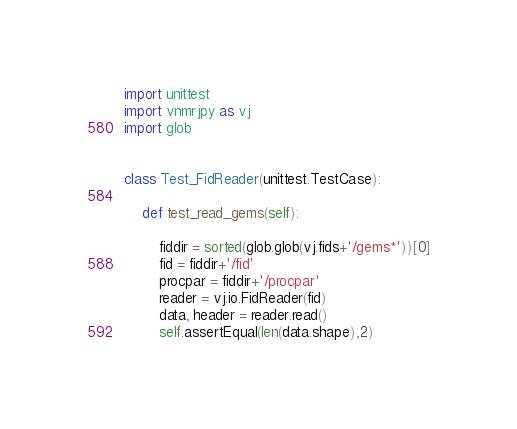<code> <loc_0><loc_0><loc_500><loc_500><_Python_>import unittest
import vnmrjpy as vj
import glob


class Test_FidReader(unittest.TestCase):

    def test_read_gems(self):

        fiddir = sorted(glob.glob(vj.fids+'/gems*'))[0]
        fid = fiddir+'/fid'
        procpar = fiddir+'/procpar'
        reader = vj.io.FidReader(fid)
        data, header = reader.read()
        self.assertEqual(len(data.shape),2)
</code> 